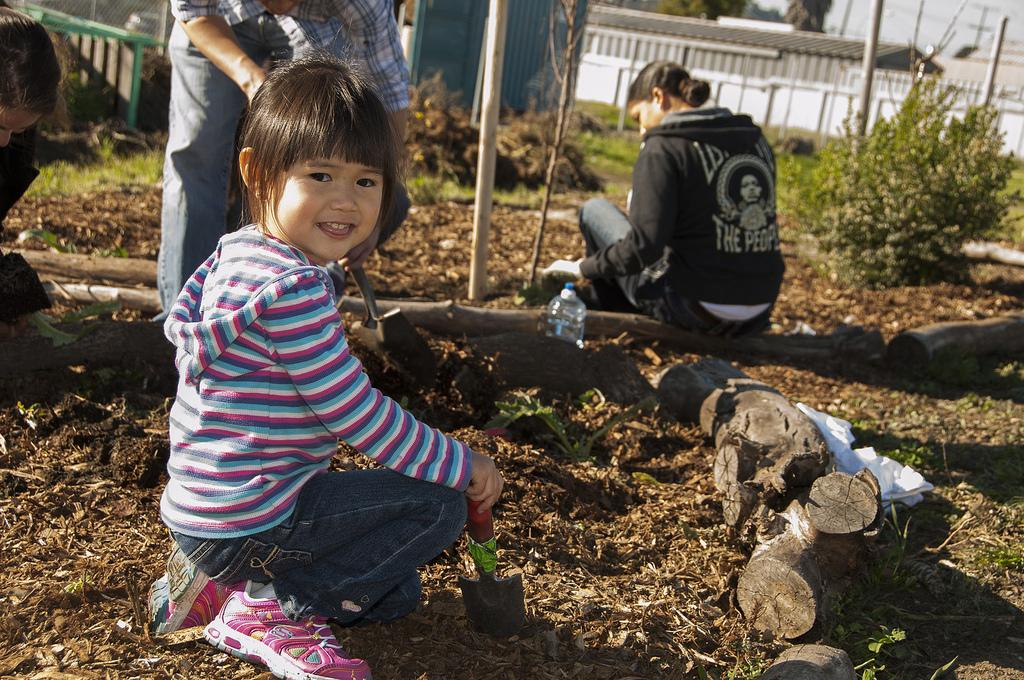How many people are in the image? There are people in the image, but the exact number is not specified. What are the people doing in the image? The people are sitting on the ground and doing some work. What objects can be seen in the image? There are wooden logs and plants visible in the image. What is visible in the background of the image? There is a wall in the background of the image. Can you tell me what type of stitch the doctor is using to treat the patient in the image? There is no doctor or patient present in the image, and therefore no such treatment can be observed. 